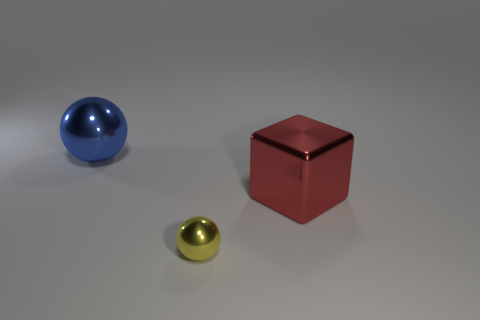What is the material of the large thing on the left side of the big red thing?
Make the answer very short. Metal. Are there fewer yellow shiny things behind the large blue object than metal balls?
Keep it short and to the point. Yes. There is a big metal object that is in front of the large object left of the yellow ball; what is its shape?
Offer a terse response. Cube. What is the color of the large sphere?
Your answer should be very brief. Blue. What number of other things are there of the same size as the shiny cube?
Your answer should be compact. 1. There is a thing that is both behind the yellow sphere and in front of the big blue shiny sphere; what material is it?
Make the answer very short. Metal. Is the size of the sphere that is behind the shiny block the same as the red block?
Offer a very short reply. Yes. Does the small metal thing have the same color as the metallic block?
Make the answer very short. No. What number of shiny things are on the right side of the tiny shiny sphere and behind the large red metallic block?
Offer a terse response. 0. How many tiny yellow metal things are behind the metal sphere on the right side of the sphere behind the large red object?
Provide a short and direct response. 0. 